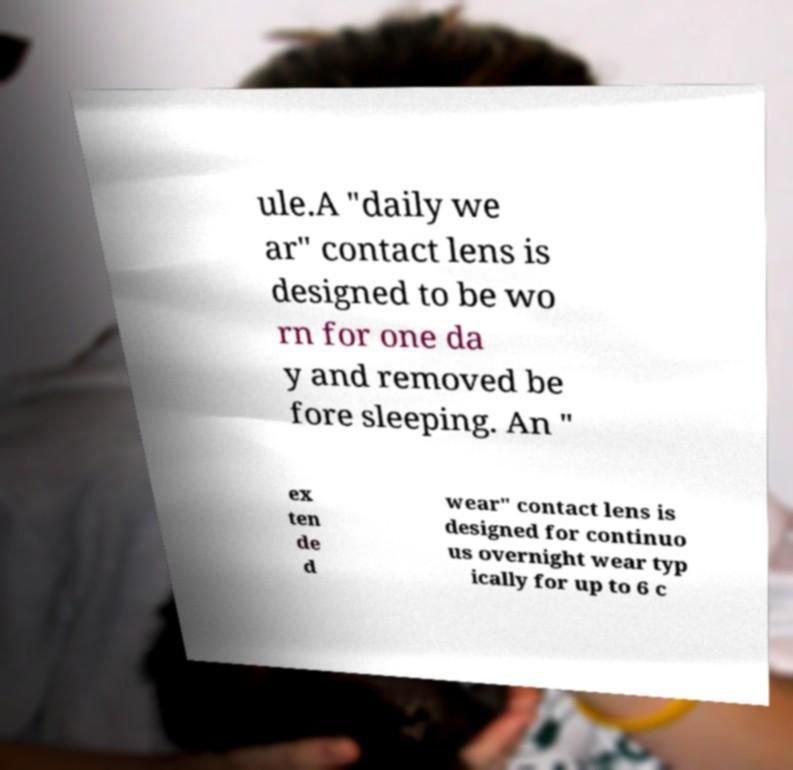Can you accurately transcribe the text from the provided image for me? ule.A "daily we ar" contact lens is designed to be wo rn for one da y and removed be fore sleeping. An " ex ten de d wear" contact lens is designed for continuo us overnight wear typ ically for up to 6 c 